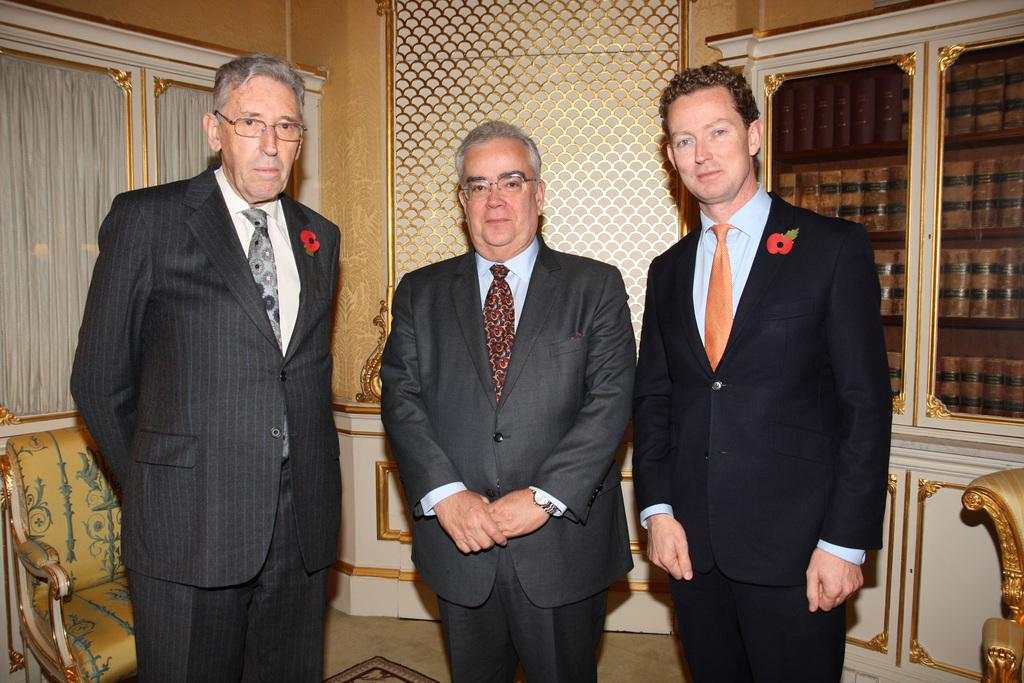What is the main subject of the image? There are people in the center of the image. What can be found inside the cupboards in the image? There are books inside the cupboards. Is there any furniture visible in the image? Yes, there is a chair in the image. What is visible on the left side of the image? There are windows on the left side of the image. Can you tell me how much the beggar weighs on the scale in the image? There is no beggar or scale present in the image. What type of beam is supporting the roof in the image? There is no beam visible in the image; it is not mentioned in the provided facts. 